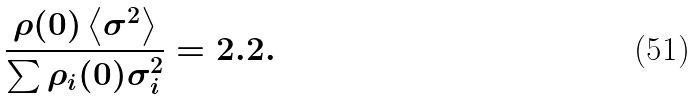<formula> <loc_0><loc_0><loc_500><loc_500>\frac { \rho ( 0 ) \left < \sigma ^ { 2 } \right > } { \sum \rho _ { i } ( 0 ) \sigma _ { i } ^ { 2 } } = 2 . 2 .</formula> 